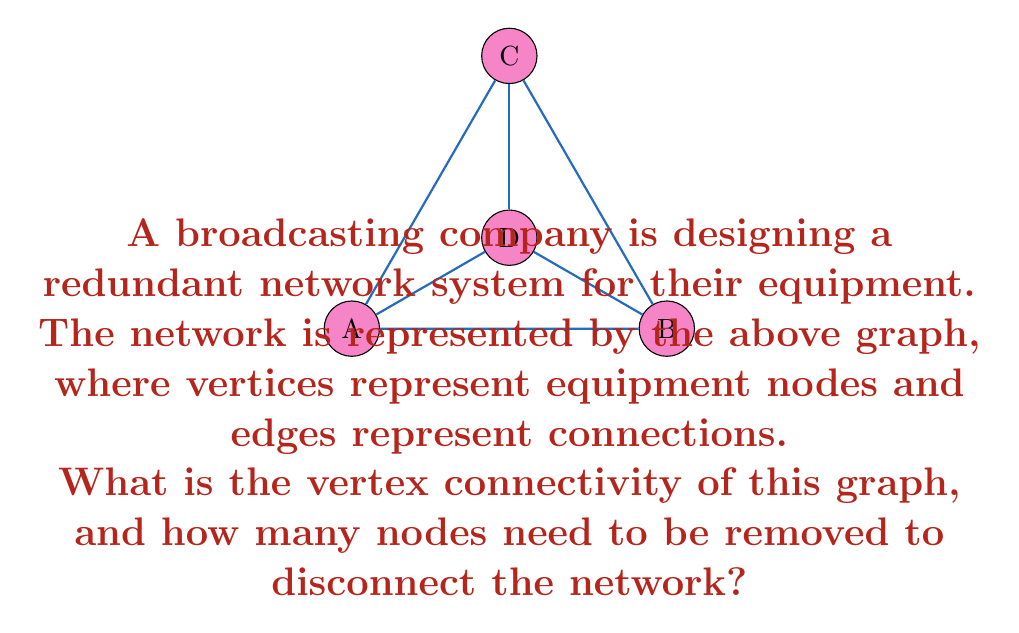Help me with this question. To solve this problem, we need to understand the concept of vertex connectivity in graph theory:

1) Vertex connectivity, denoted as $\kappa(G)$, is the minimum number of vertices that need to be removed to disconnect the graph.

2) For this graph, we can analyze it step by step:

   a) The graph has 4 vertices (A, B, C, D) and 6 edges.
   b) It forms a complete graph K3 (A, B, C) with an additional vertex D connected to all vertices of the K3.

3) To disconnect this graph:
   - Removing any single vertex will not disconnect the graph.
   - Removing any two vertices will always disconnect the graph.

4) Therefore, the vertex connectivity of this graph is 2.

5) This means that a minimum of 2 nodes need to be removed to disconnect the network.

In the context of broadcasting systems, this implies that the network has a moderate level of redundancy. It can withstand the failure of any single equipment node without losing overall connectivity, but the failure of any two nodes will disrupt the network.
Answer: $\kappa(G) = 2$ 